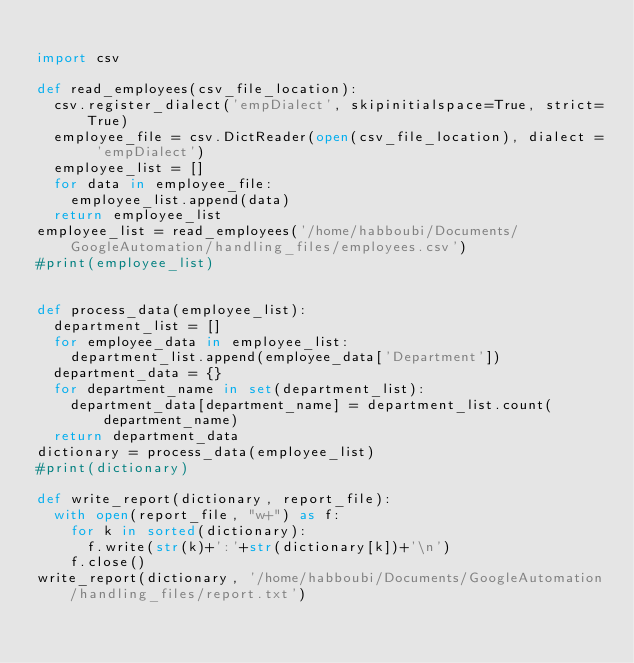Convert code to text. <code><loc_0><loc_0><loc_500><loc_500><_Python_>
import csv

def read_employees(csv_file_location):
  csv.register_dialect('empDialect', skipinitialspace=True, strict=True)
  employee_file = csv.DictReader(open(csv_file_location), dialect = 'empDialect')
  employee_list = []
  for data in employee_file:
    employee_list.append(data)
  return employee_list
employee_list = read_employees('/home/habboubi/Documents/GoogleAutomation/handling_files/employees.csv')
#print(employee_list)


def process_data(employee_list):
  department_list = []
  for employee_data in employee_list:
    department_list.append(employee_data['Department'])
  department_data = {}
  for department_name in set(department_list):
    department_data[department_name] = department_list.count(department_name)
  return department_data
dictionary = process_data(employee_list)
#print(dictionary)

def write_report(dictionary, report_file):
  with open(report_file, "w+") as f:
    for k in sorted(dictionary):
      f.write(str(k)+':'+str(dictionary[k])+'\n')
    f.close()
write_report(dictionary, '/home/habboubi/Documents/GoogleAutomation/handling_files/report.txt')
</code> 